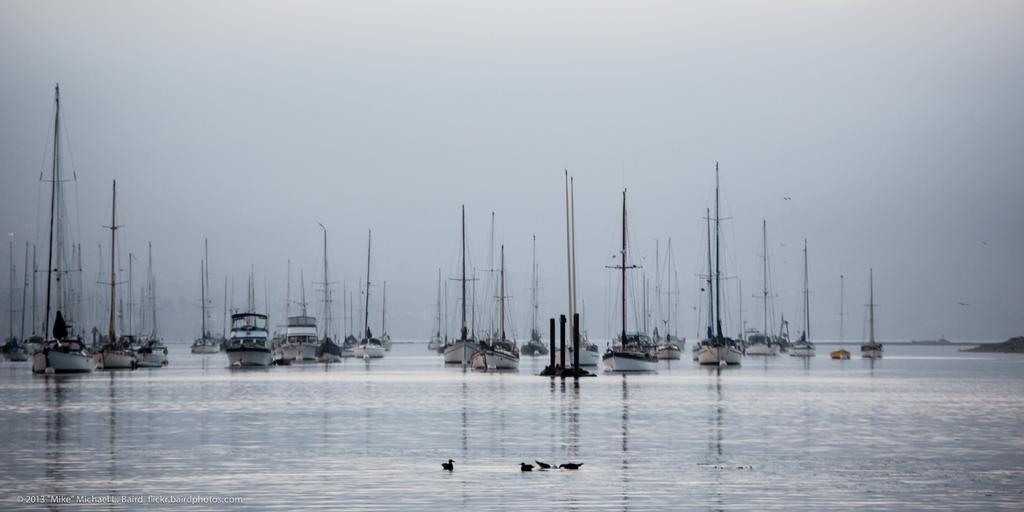What type of vehicles are in the image? There are boats in the image. What other living creatures can be seen in the image? There are birds in the image. Where are the birds located in the image? The birds are on the water, as mentioned in fact 3. What can be seen in the background of the image? The sky is visible in the background of the image. Is there any additional information about the image itself? Yes, there is a watermark in the bottom left corner of the image. Absurd Question/Answer: What type of flower is growing on the boats in the image? There are no flowers growing on the boats in the image. What fact can be learned about the birds in the image? The provided facts do not mention any specific facts about the birds; they only mention their presence and location. 